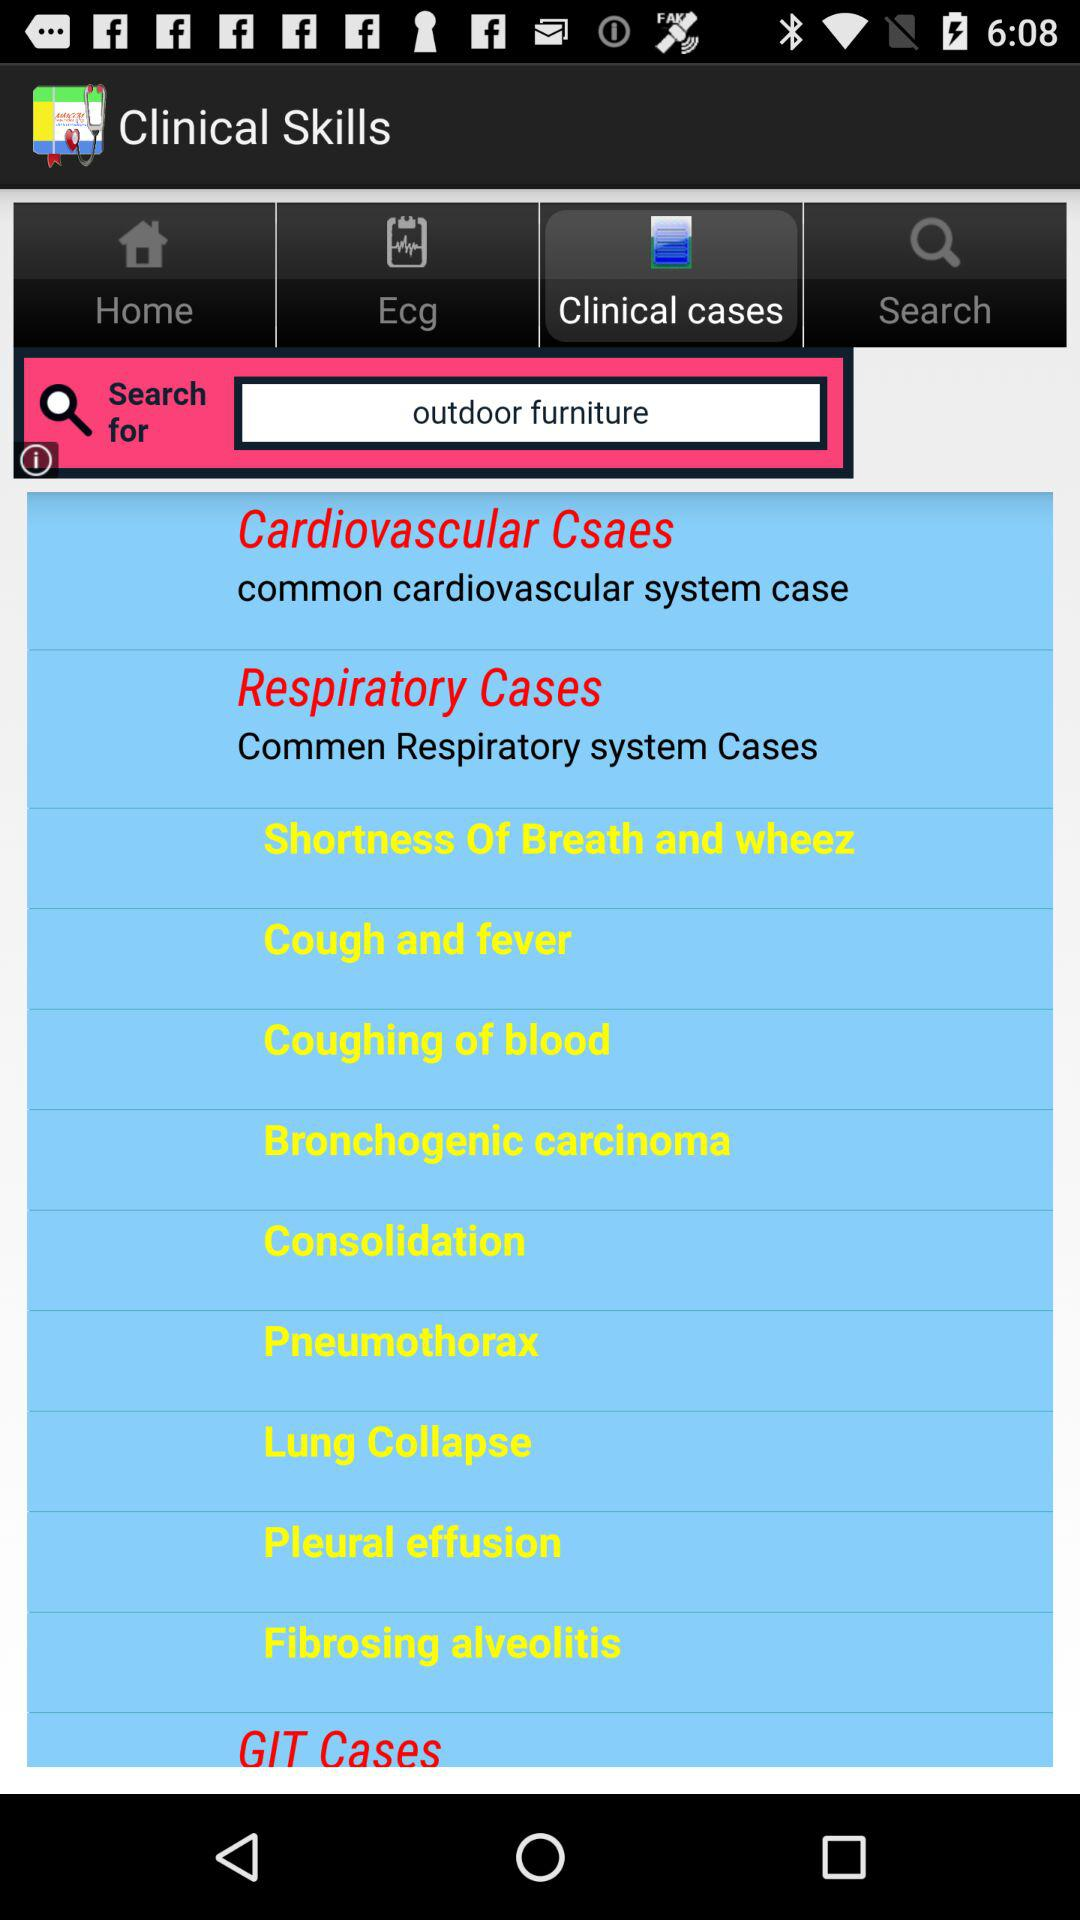What is the application name? The application name is "Clinical Skills". 